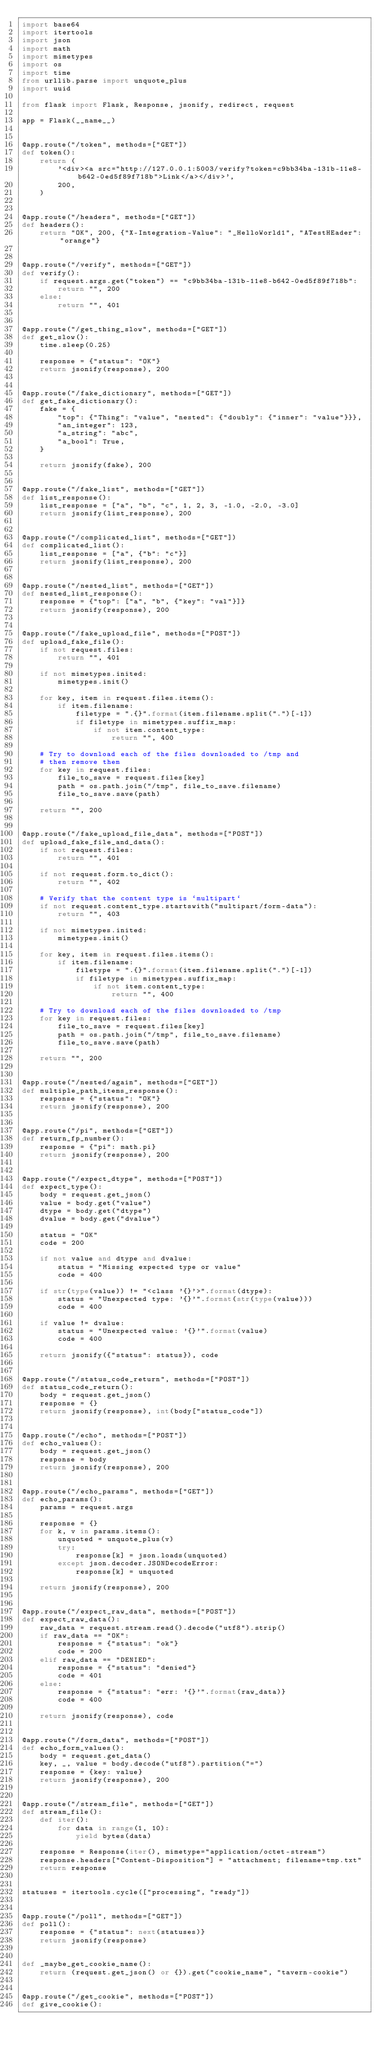Convert code to text. <code><loc_0><loc_0><loc_500><loc_500><_Python_>import base64
import itertools
import json
import math
import mimetypes
import os
import time
from urllib.parse import unquote_plus
import uuid

from flask import Flask, Response, jsonify, redirect, request

app = Flask(__name__)


@app.route("/token", methods=["GET"])
def token():
    return (
        '<div><a src="http://127.0.0.1:5003/verify?token=c9bb34ba-131b-11e8-b642-0ed5f89f718b">Link</a></div>',
        200,
    )


@app.route("/headers", methods=["GET"])
def headers():
    return "OK", 200, {"X-Integration-Value": "_HelloWorld1", "ATestHEader": "orange"}


@app.route("/verify", methods=["GET"])
def verify():
    if request.args.get("token") == "c9bb34ba-131b-11e8-b642-0ed5f89f718b":
        return "", 200
    else:
        return "", 401


@app.route("/get_thing_slow", methods=["GET"])
def get_slow():
    time.sleep(0.25)

    response = {"status": "OK"}
    return jsonify(response), 200


@app.route("/fake_dictionary", methods=["GET"])
def get_fake_dictionary():
    fake = {
        "top": {"Thing": "value", "nested": {"doubly": {"inner": "value"}}},
        "an_integer": 123,
        "a_string": "abc",
        "a_bool": True,
    }

    return jsonify(fake), 200


@app.route("/fake_list", methods=["GET"])
def list_response():
    list_response = ["a", "b", "c", 1, 2, 3, -1.0, -2.0, -3.0]
    return jsonify(list_response), 200


@app.route("/complicated_list", methods=["GET"])
def complicated_list():
    list_response = ["a", {"b": "c"}]
    return jsonify(list_response), 200


@app.route("/nested_list", methods=["GET"])
def nested_list_response():
    response = {"top": ["a", "b", {"key": "val"}]}
    return jsonify(response), 200


@app.route("/fake_upload_file", methods=["POST"])
def upload_fake_file():
    if not request.files:
        return "", 401

    if not mimetypes.inited:
        mimetypes.init()

    for key, item in request.files.items():
        if item.filename:
            filetype = ".{}".format(item.filename.split(".")[-1])
            if filetype in mimetypes.suffix_map:
                if not item.content_type:
                    return "", 400

    # Try to download each of the files downloaded to /tmp and
    # then remove them
    for key in request.files:
        file_to_save = request.files[key]
        path = os.path.join("/tmp", file_to_save.filename)
        file_to_save.save(path)

    return "", 200


@app.route("/fake_upload_file_data", methods=["POST"])
def upload_fake_file_and_data():
    if not request.files:
        return "", 401

    if not request.form.to_dict():
        return "", 402

    # Verify that the content type is `multipart`
    if not request.content_type.startswith("multipart/form-data"):
        return "", 403

    if not mimetypes.inited:
        mimetypes.init()

    for key, item in request.files.items():
        if item.filename:
            filetype = ".{}".format(item.filename.split(".")[-1])
            if filetype in mimetypes.suffix_map:
                if not item.content_type:
                    return "", 400

    # Try to download each of the files downloaded to /tmp
    for key in request.files:
        file_to_save = request.files[key]
        path = os.path.join("/tmp", file_to_save.filename)
        file_to_save.save(path)

    return "", 200


@app.route("/nested/again", methods=["GET"])
def multiple_path_items_response():
    response = {"status": "OK"}
    return jsonify(response), 200


@app.route("/pi", methods=["GET"])
def return_fp_number():
    response = {"pi": math.pi}
    return jsonify(response), 200


@app.route("/expect_dtype", methods=["POST"])
def expect_type():
    body = request.get_json()
    value = body.get("value")
    dtype = body.get("dtype")
    dvalue = body.get("dvalue")

    status = "OK"
    code = 200

    if not value and dtype and dvalue:
        status = "Missing expected type or value"
        code = 400

    if str(type(value)) != "<class '{}'>".format(dtype):
        status = "Unexpected type: '{}'".format(str(type(value)))
        code = 400

    if value != dvalue:
        status = "Unexpected value: '{}'".format(value)
        code = 400

    return jsonify({"status": status}), code


@app.route("/status_code_return", methods=["POST"])
def status_code_return():
    body = request.get_json()
    response = {}
    return jsonify(response), int(body["status_code"])


@app.route("/echo", methods=["POST"])
def echo_values():
    body = request.get_json()
    response = body
    return jsonify(response), 200


@app.route("/echo_params", methods=["GET"])
def echo_params():
    params = request.args

    response = {}
    for k, v in params.items():
        unquoted = unquote_plus(v)
        try:
            response[k] = json.loads(unquoted)
        except json.decoder.JSONDecodeError:
            response[k] = unquoted

    return jsonify(response), 200


@app.route("/expect_raw_data", methods=["POST"])
def expect_raw_data():
    raw_data = request.stream.read().decode("utf8").strip()
    if raw_data == "OK":
        response = {"status": "ok"}
        code = 200
    elif raw_data == "DENIED":
        response = {"status": "denied"}
        code = 401
    else:
        response = {"status": "err: '{}'".format(raw_data)}
        code = 400

    return jsonify(response), code


@app.route("/form_data", methods=["POST"])
def echo_form_values():
    body = request.get_data()
    key, _, value = body.decode("utf8").partition("=")
    response = {key: value}
    return jsonify(response), 200


@app.route("/stream_file", methods=["GET"])
def stream_file():
    def iter():
        for data in range(1, 10):
            yield bytes(data)

    response = Response(iter(), mimetype="application/octet-stream")
    response.headers["Content-Disposition"] = "attachment; filename=tmp.txt"
    return response


statuses = itertools.cycle(["processing", "ready"])


@app.route("/poll", methods=["GET"])
def poll():
    response = {"status": next(statuses)}
    return jsonify(response)


def _maybe_get_cookie_name():
    return (request.get_json() or {}).get("cookie_name", "tavern-cookie")


@app.route("/get_cookie", methods=["POST"])
def give_cookie():</code> 